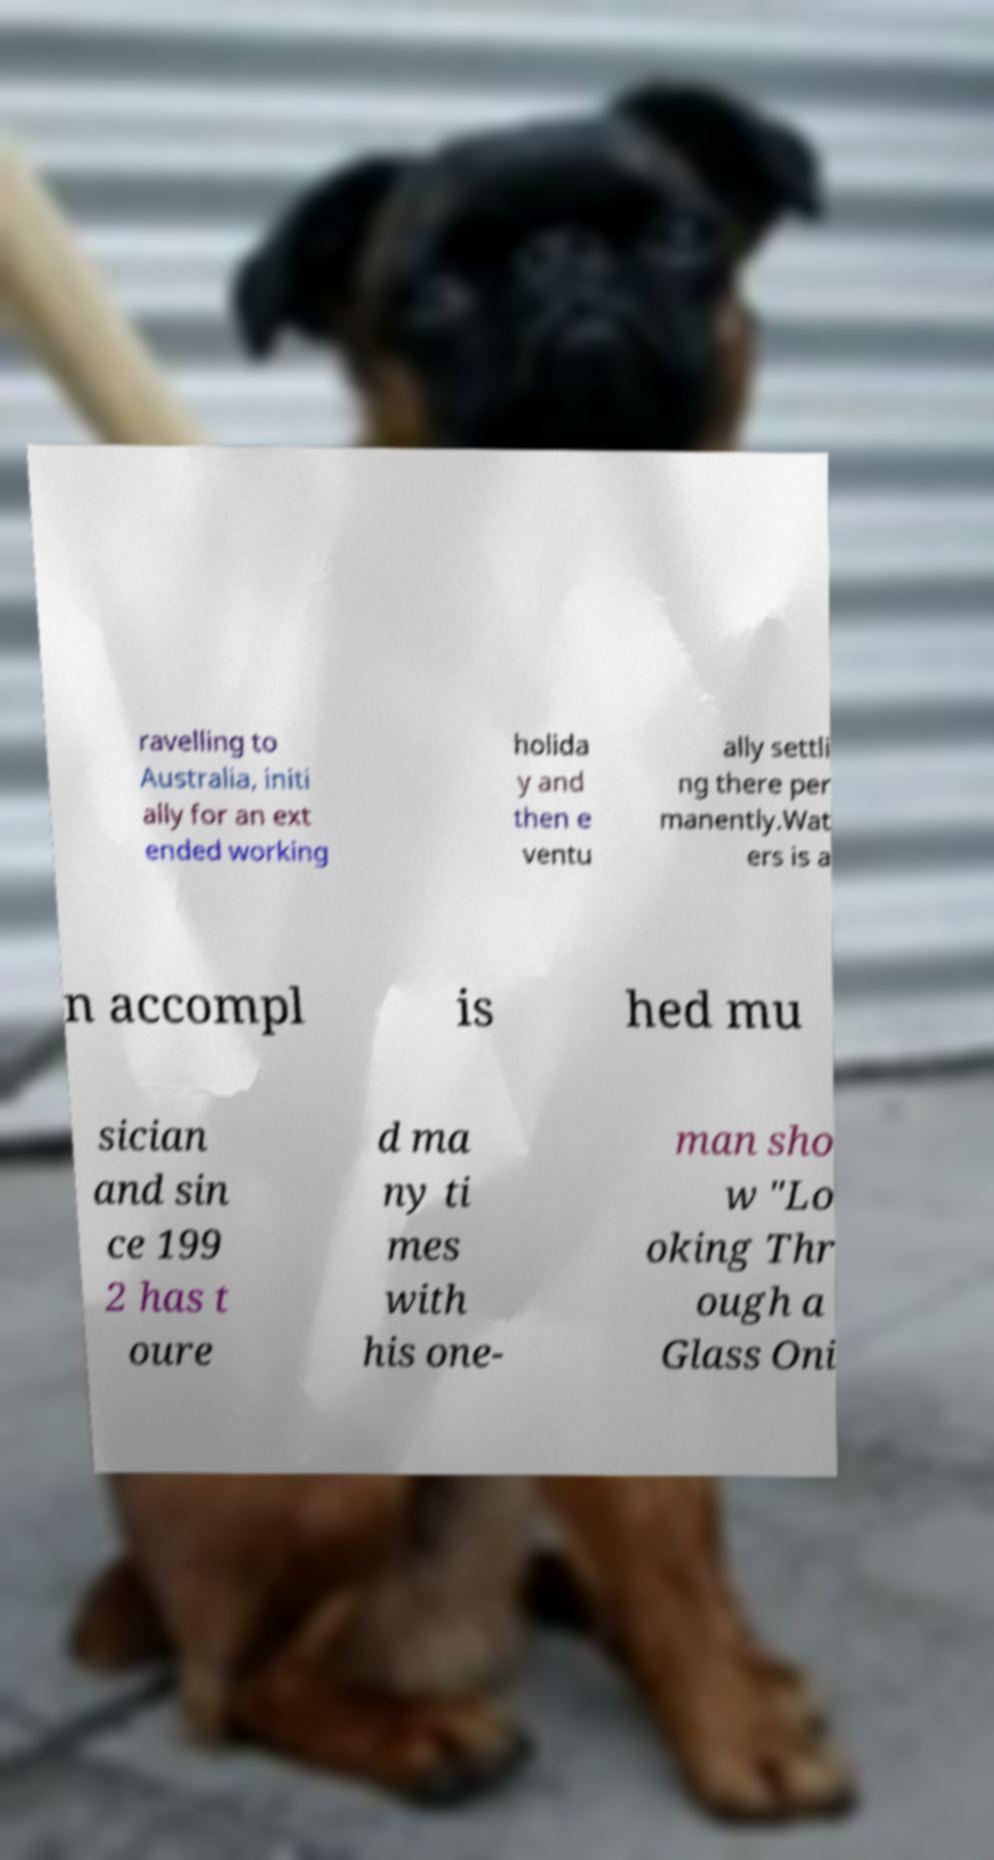What messages or text are displayed in this image? I need them in a readable, typed format. ravelling to Australia, initi ally for an ext ended working holida y and then e ventu ally settli ng there per manently.Wat ers is a n accompl is hed mu sician and sin ce 199 2 has t oure d ma ny ti mes with his one- man sho w "Lo oking Thr ough a Glass Oni 